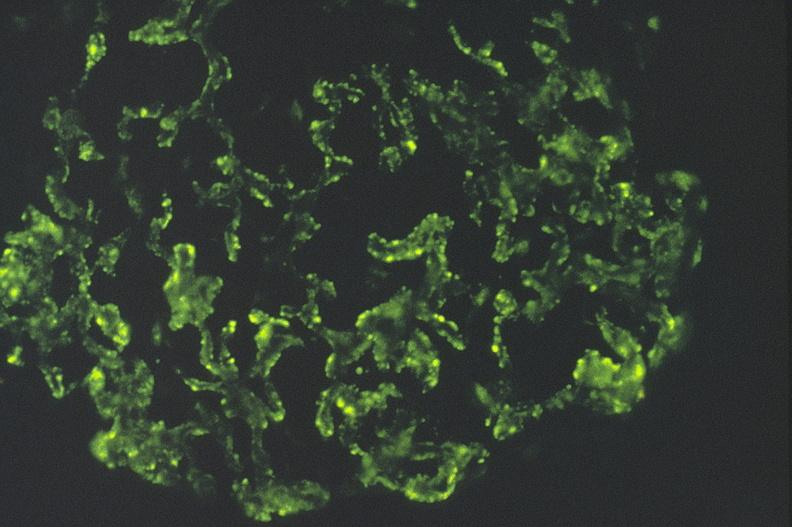s uremic frost present?
Answer the question using a single word or phrase. No 